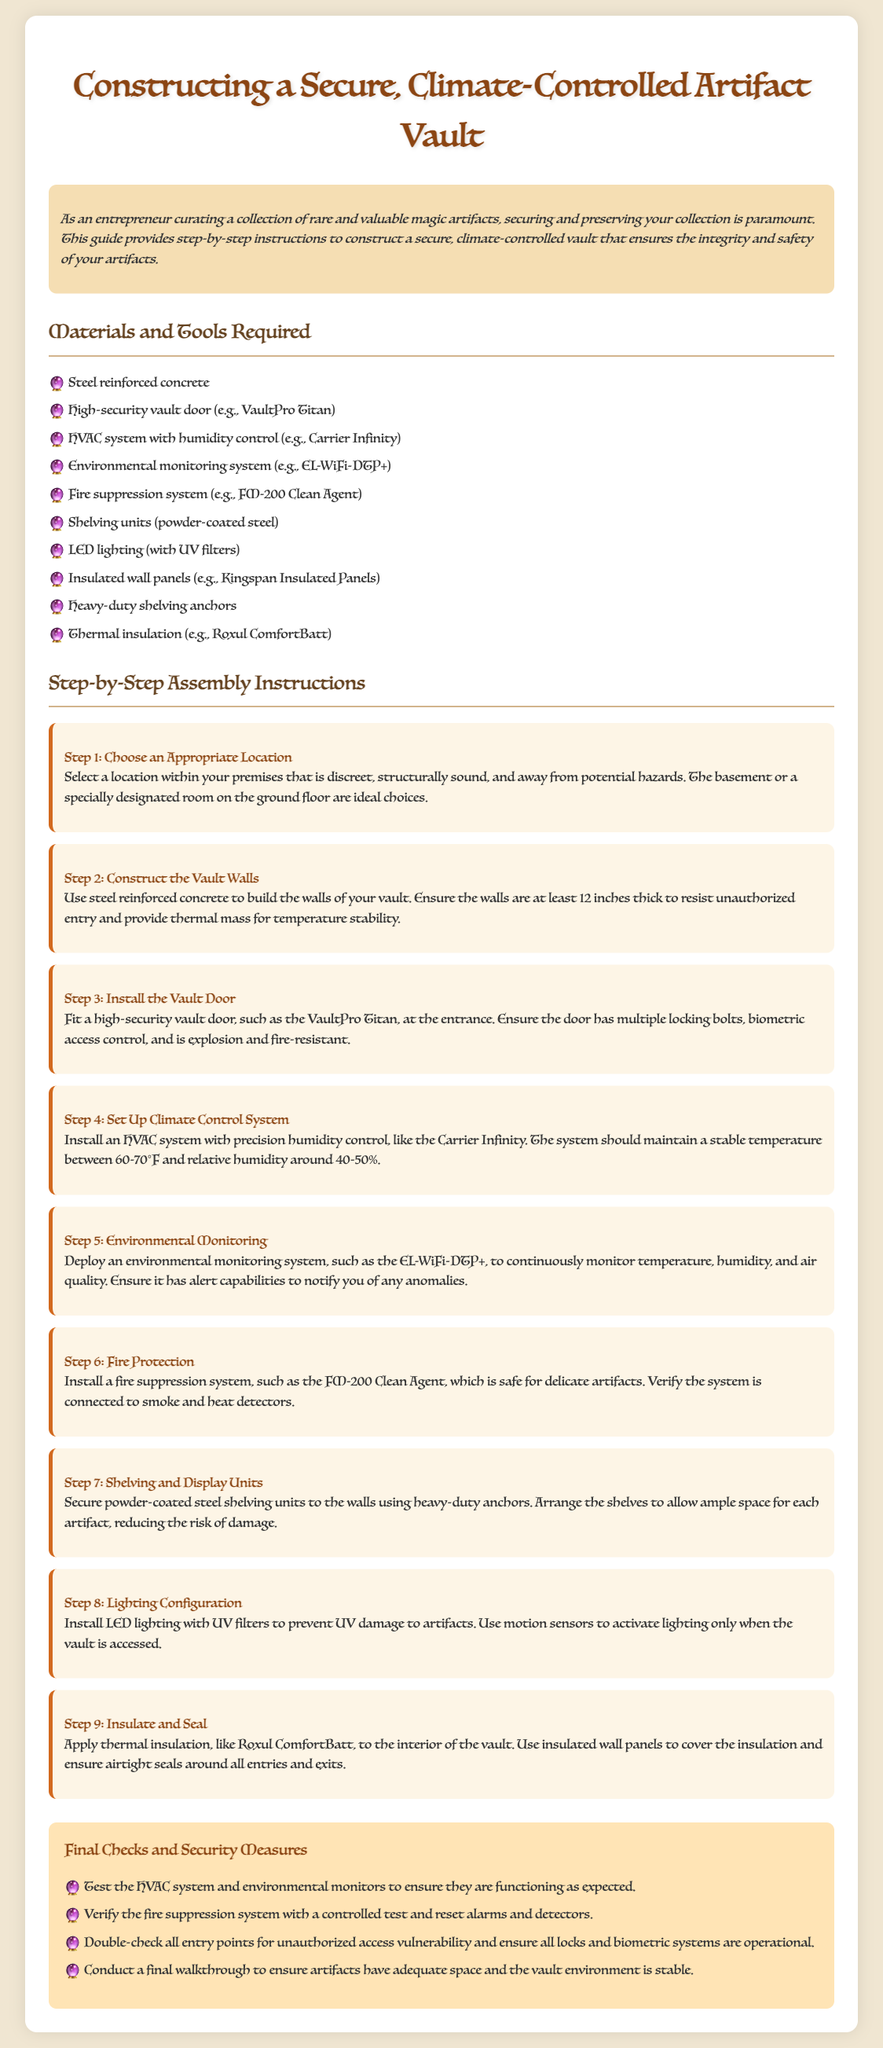what is the title of the document? The title appears at the top of the document and provides the main subject of the assembly instructions.
Answer: Constructing a Secure, Climate-Controlled Artifact Vault how thick should the vault walls be? The specification for wall thickness is clearly stated in the steps for constructing the vault walls.
Answer: 12 inches what type of vault door is recommended? The recommended vault door is mentioned in Step 3 of the assembly instructions.
Answer: VaultPro Titan what is the ideal temperature range for the climate control system? The step for setting up the climate control system includes the required temperature range for optimal artifact preservation.
Answer: 60-70°F which fire suppression system is suggested? The assembly instructions specify a particular fire suppression system that is suitable for delicate artifacts.
Answer: FM-200 Clean Agent what should be installed to monitor the environment continuously? The specific system that needs to be deployed for environmental monitoring is listed in Step 5.
Answer: EL-WiFi-DTP+ what is used for thermal insulation in the vault? The materials for thermal insulation are named in Step 9, indicating their relevance to energy efficiency and artifact safety.
Answer: Roxul ComfortBatt why should LED lighting have UV filters? The document outlines the reasoning behind using specific lighting to protect the artifacts.
Answer: To prevent UV damage what measures are suggested for final checks? The section for final checks outlines steps to ensure the security and functionality of the vault.
Answer: Test HVAC system and environmental monitors 